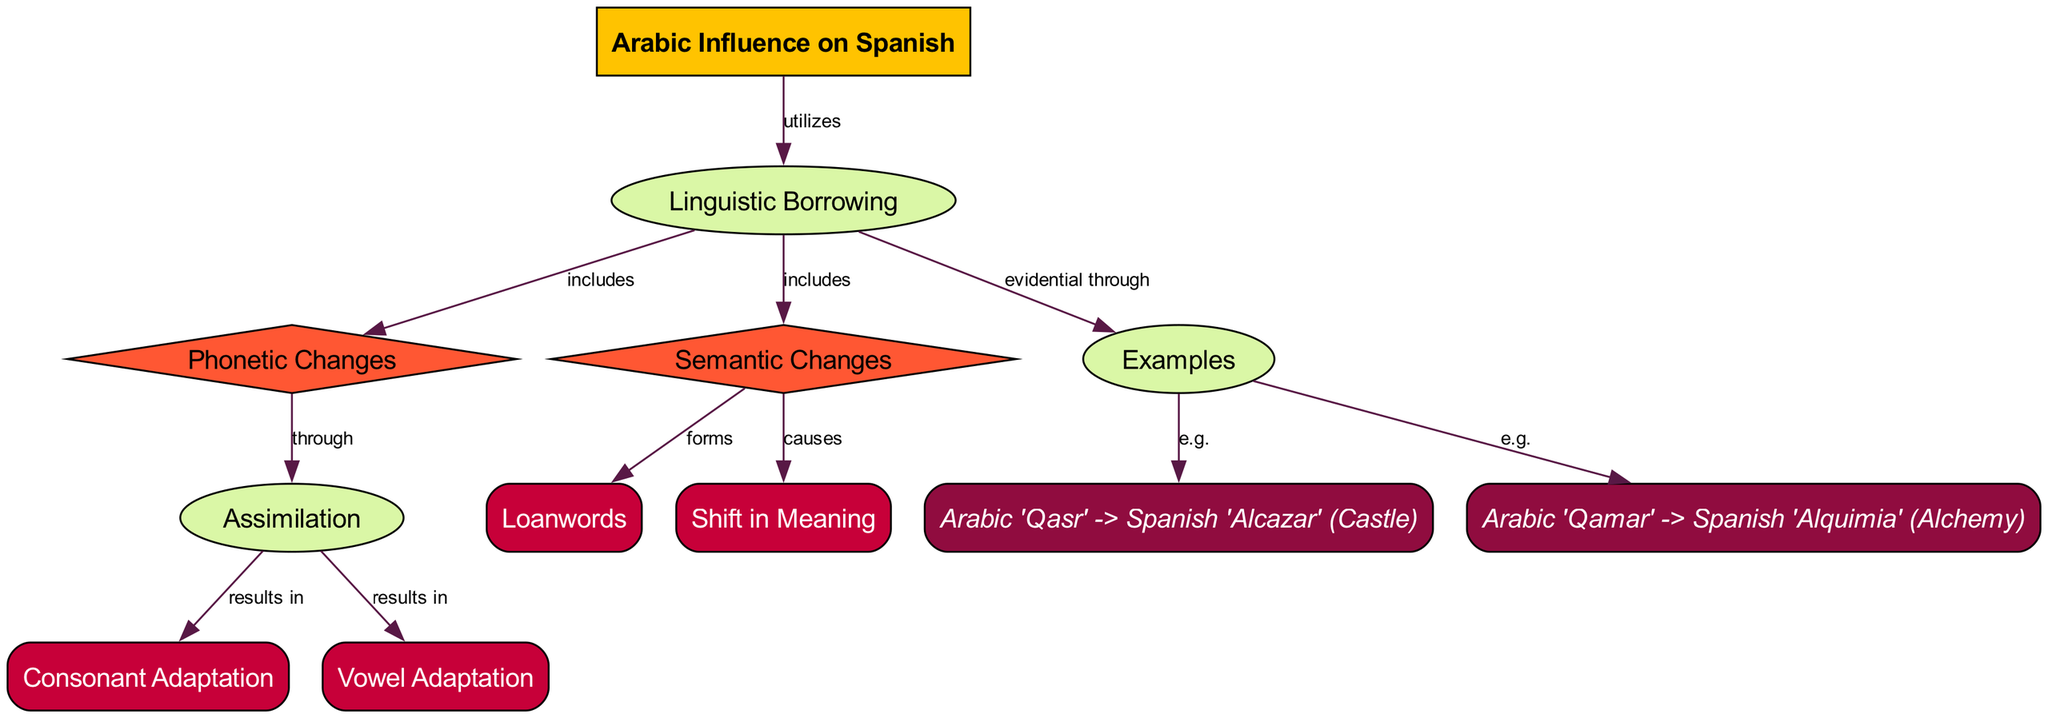What is the main topic of the diagram? The main node labeled "Arabic Influence on Spanish" indicates the central theme of the diagram. This is the starting point from which all other processes and categories derive.
Answer: Arabic Influence on Spanish How many processes are present in the diagram? By counting the nodes labeled as "process," we find two: "Linguistic Borrowing" and "Examples." Therefore, there are two processes.
Answer: 2 What are the two categories included in the linguistic borrowing process? The diagram lists "Phonetic Changes" and "Semantic Changes" as the categories under the "Linguistic Borrowing" process. This can be confirmed by direct observation of the edges leading from "Linguistic Borrowing."
Answer: Phonetic Changes, Semantic Changes Which element results from consonant adaptation? The diagram shows an edge from "Consonant Adaptation" to "Assimilation," indicating that consonant adaptation leads to assimilation as a result.
Answer: Assimilation What causes a shift in meaning? According to the diagram, a "Shift in Meaning" is caused by "Semantic Changes," as it is directly linked with an edge labeled "causes."
Answer: Semantic Changes What are the examples provided in the diagram? The diagram indicates two specific examples of linguistic borrowing: 1) Arabic 'Qasr' -> Spanish 'Alcazar' (Castle) and 2) Arabic 'Qamar' -> Spanish 'Alquimia' (Alchemy). These are listed under the examples process and can be easily identified as specific cases of borrowing.
Answer: Arabic 'Qasr' -> Spanish 'Alcazar', Arabic 'Qamar' -> Spanish 'Alquimia' What specifically results from assimilation in phonetic changes? The diagram distinctly shows that "Assimilation" is a process leading to both "Consonant Adaptation" and "Vowel Adaptation," indicating their outcomes from the process of assimilation concerning phonetic changes.
Answer: Consonant Adaptation, Vowel Adaptation How does semantic change contribute to loanwords? The diagram highlights that "Semantic Changes" directly forms "Loanwords." This means that through semantic changes, new loanwords are created in the Spanish language.
Answer: Loanwords Which two elements represent the categories of phonetic changes? The edges indicate that "Consonant Adaptation" and "Vowel Adaptation" are the two specific elements that fall under the category of "Phonetic Changes," showing the adaptations within phonetics.
Answer: Consonant Adaptation, Vowel Adaptation 